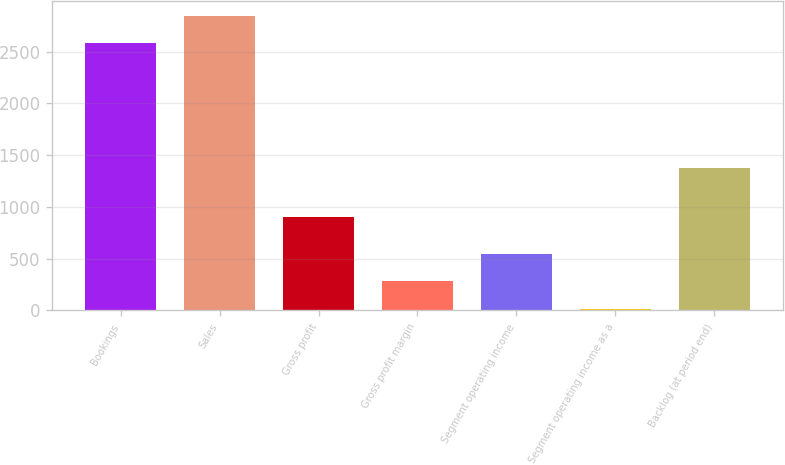Convert chart to OTSL. <chart><loc_0><loc_0><loc_500><loc_500><bar_chart><fcel>Bookings<fcel>Sales<fcel>Gross profit<fcel>Gross profit margin<fcel>Segment operating income<fcel>Segment operating income as a<fcel>Backlog (at period end)<nl><fcel>2581.7<fcel>2845.06<fcel>903.6<fcel>280.16<fcel>543.52<fcel>16.8<fcel>1379.8<nl></chart> 